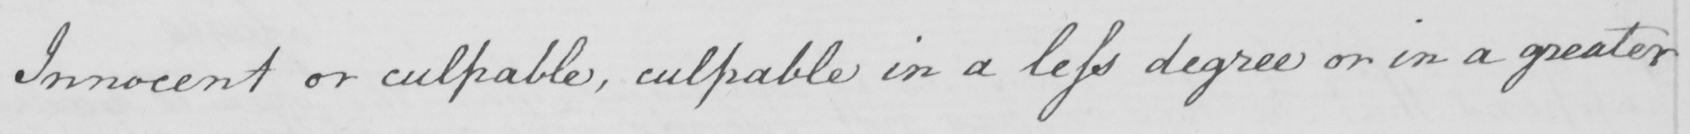Transcribe the text shown in this historical manuscript line. Innocent or culpable , culpable in a less degree or in a greater 